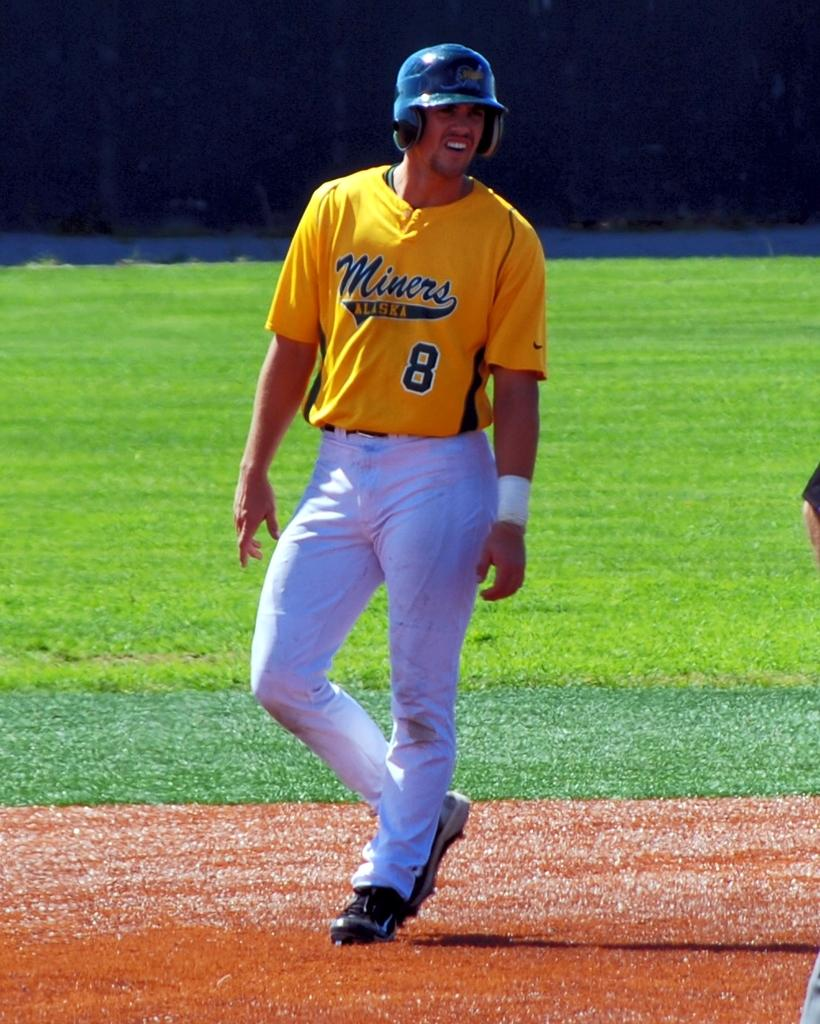Provide a one-sentence caption for the provided image. Number 8 for the Miners baseball team looks like he just got a hit. 